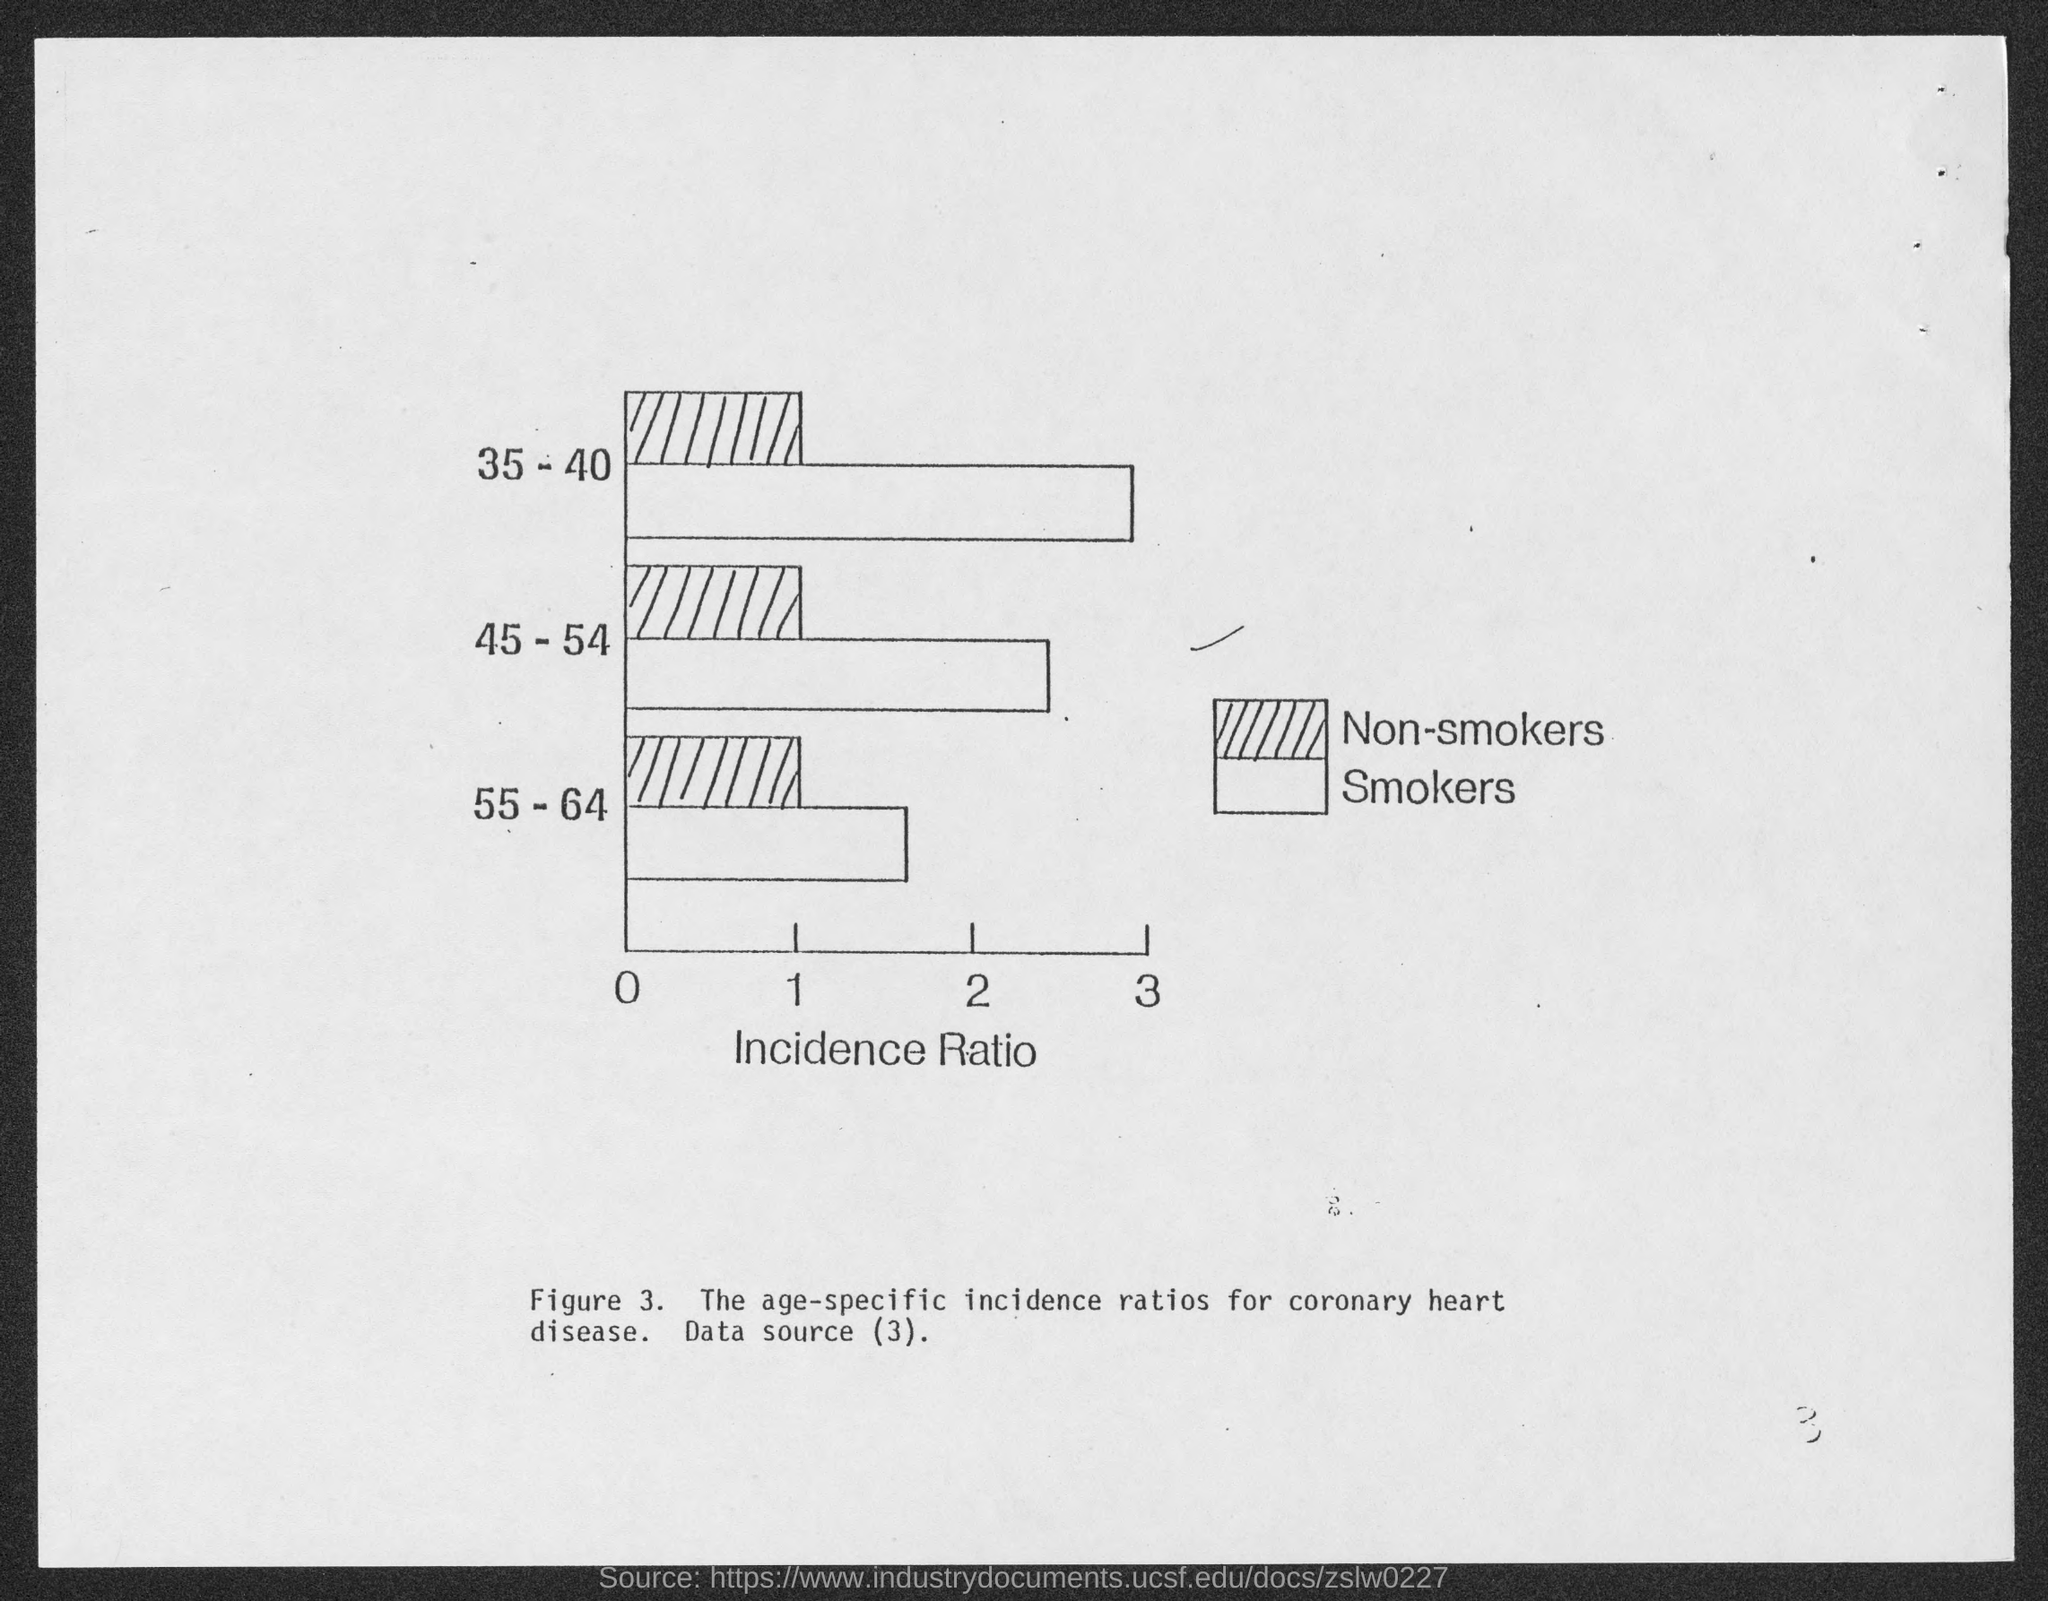Identify some key points in this picture. The incidence ratio is written on the x-axis of the figure. 